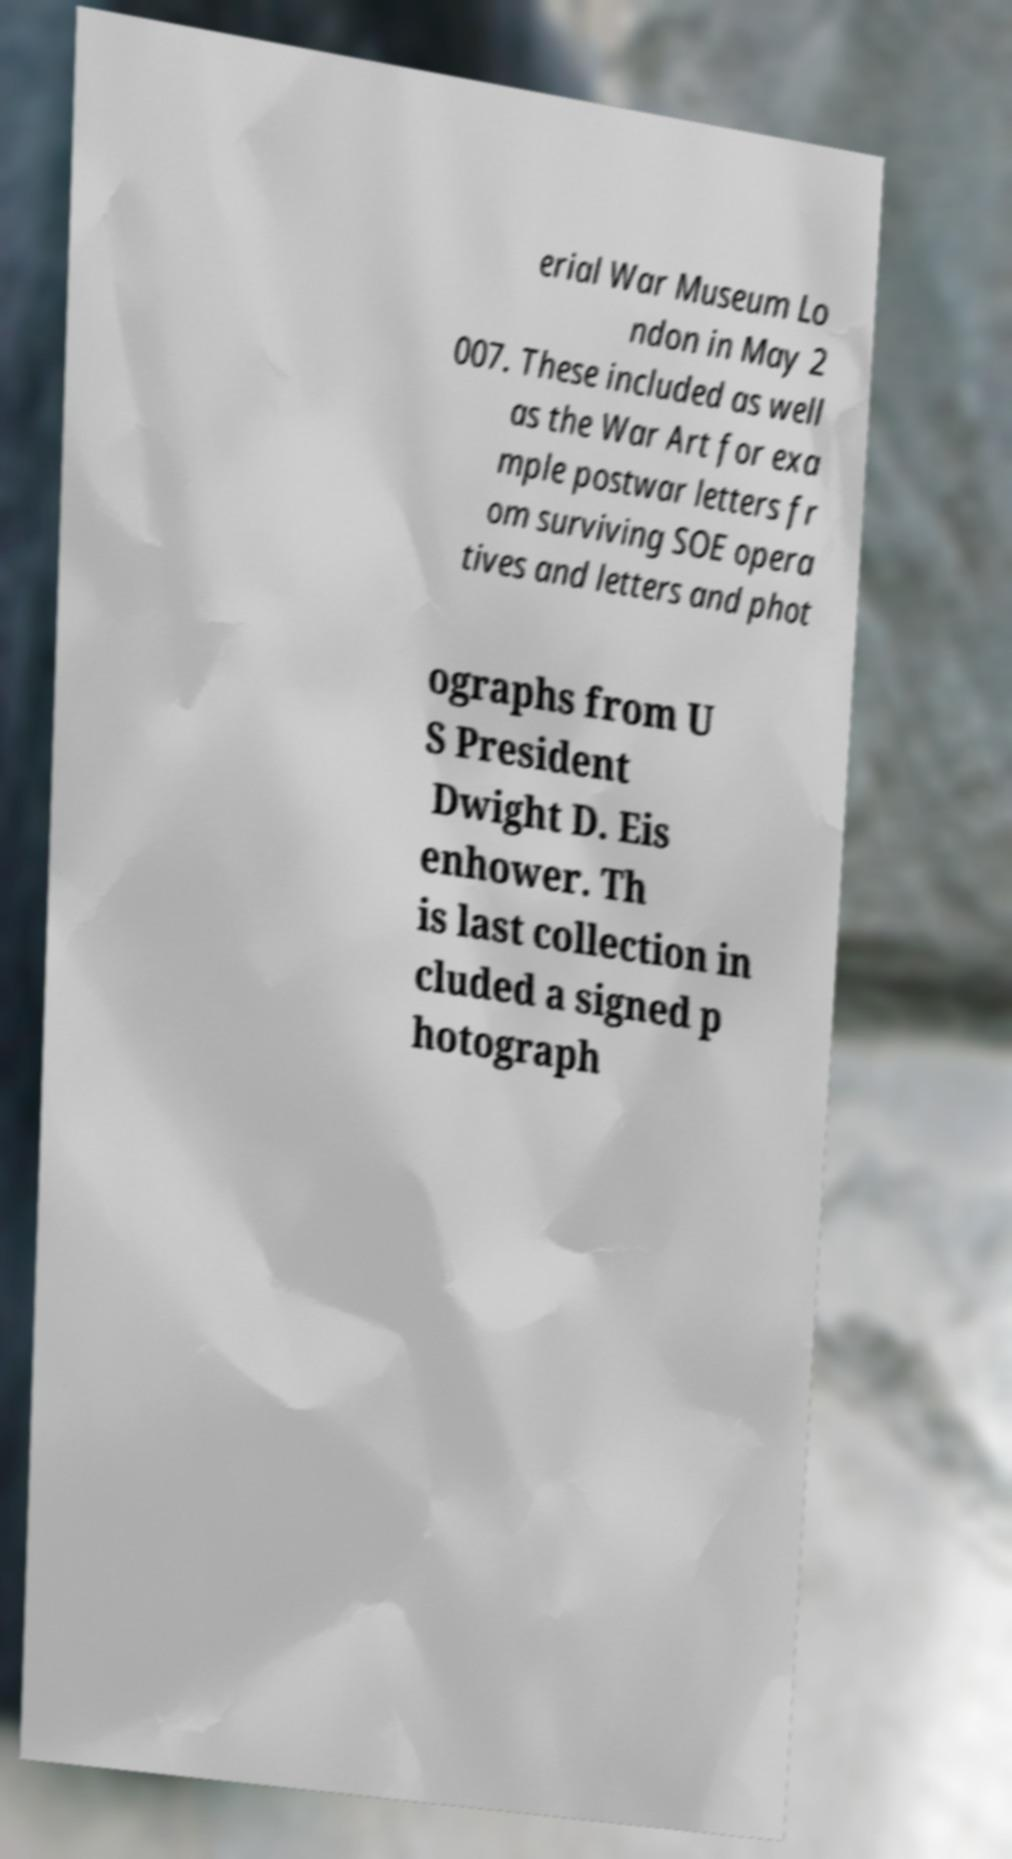Could you extract and type out the text from this image? erial War Museum Lo ndon in May 2 007. These included as well as the War Art for exa mple postwar letters fr om surviving SOE opera tives and letters and phot ographs from U S President Dwight D. Eis enhower. Th is last collection in cluded a signed p hotograph 